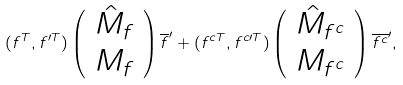Convert formula to latex. <formula><loc_0><loc_0><loc_500><loc_500>( f ^ { T } , f ^ { \prime T } ) \left ( \begin{array} { c } \hat { M } _ { f } \\ M _ { f } \end{array} \right ) \overline { f } ^ { \prime } + ( f ^ { c T } , f ^ { c \prime T } ) \left ( \begin{array} { c } \hat { M } _ { f ^ { c } } \\ M _ { f ^ { c } } \end{array} \right ) \overline { f ^ { c } } ^ { \prime } ,</formula> 